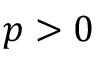<formula> <loc_0><loc_0><loc_500><loc_500>p > 0</formula> 